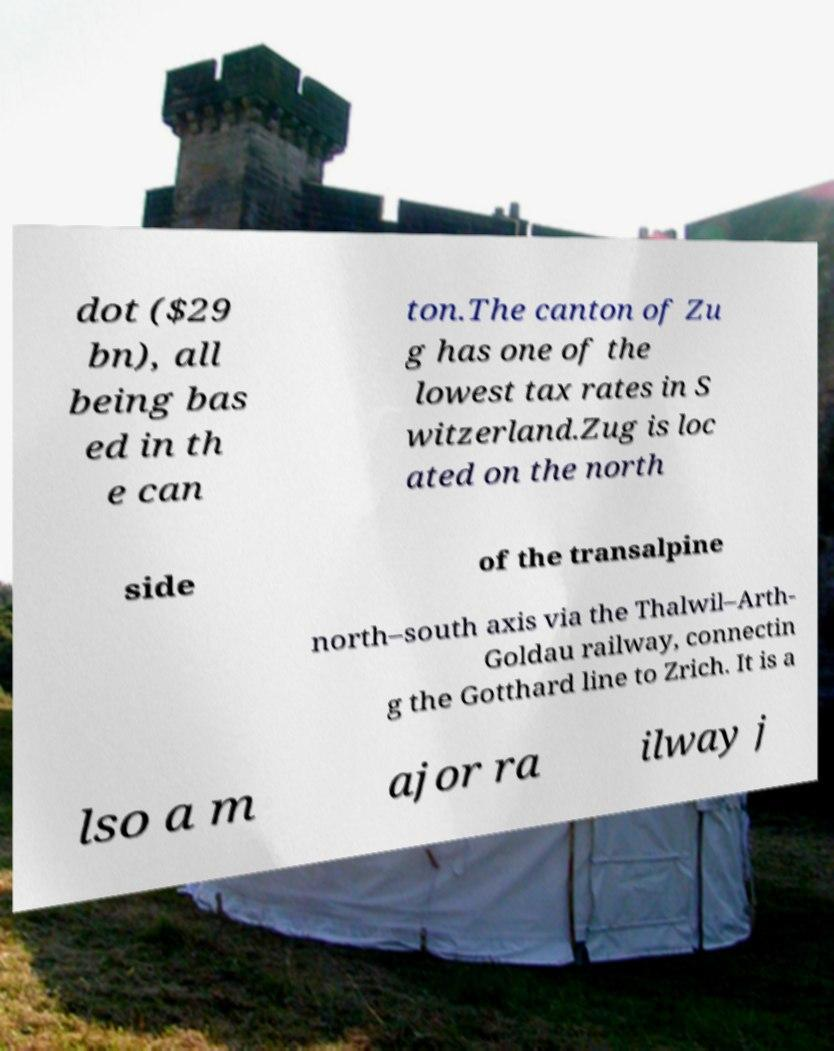For documentation purposes, I need the text within this image transcribed. Could you provide that? dot ($29 bn), all being bas ed in th e can ton.The canton of Zu g has one of the lowest tax rates in S witzerland.Zug is loc ated on the north side of the transalpine north–south axis via the Thalwil–Arth- Goldau railway, connectin g the Gotthard line to Zrich. It is a lso a m ajor ra ilway j 